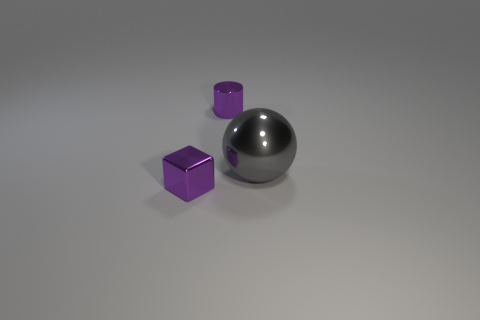Add 2 small purple metal cylinders. How many objects exist? 5 Subtract all balls. How many objects are left? 2 Add 3 small purple cylinders. How many small purple cylinders are left? 4 Add 1 big gray metallic spheres. How many big gray metallic spheres exist? 2 Subtract 1 purple cylinders. How many objects are left? 2 Subtract all gray rubber cylinders. Subtract all metal balls. How many objects are left? 2 